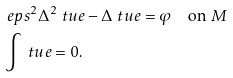<formula> <loc_0><loc_0><loc_500><loc_500>& \ e p s ^ { 2 } \Delta ^ { 2 } \ t u e - \Delta \ t u e = \varphi \quad \text {on} \ M \\ & \int \ t u e = 0 .</formula> 